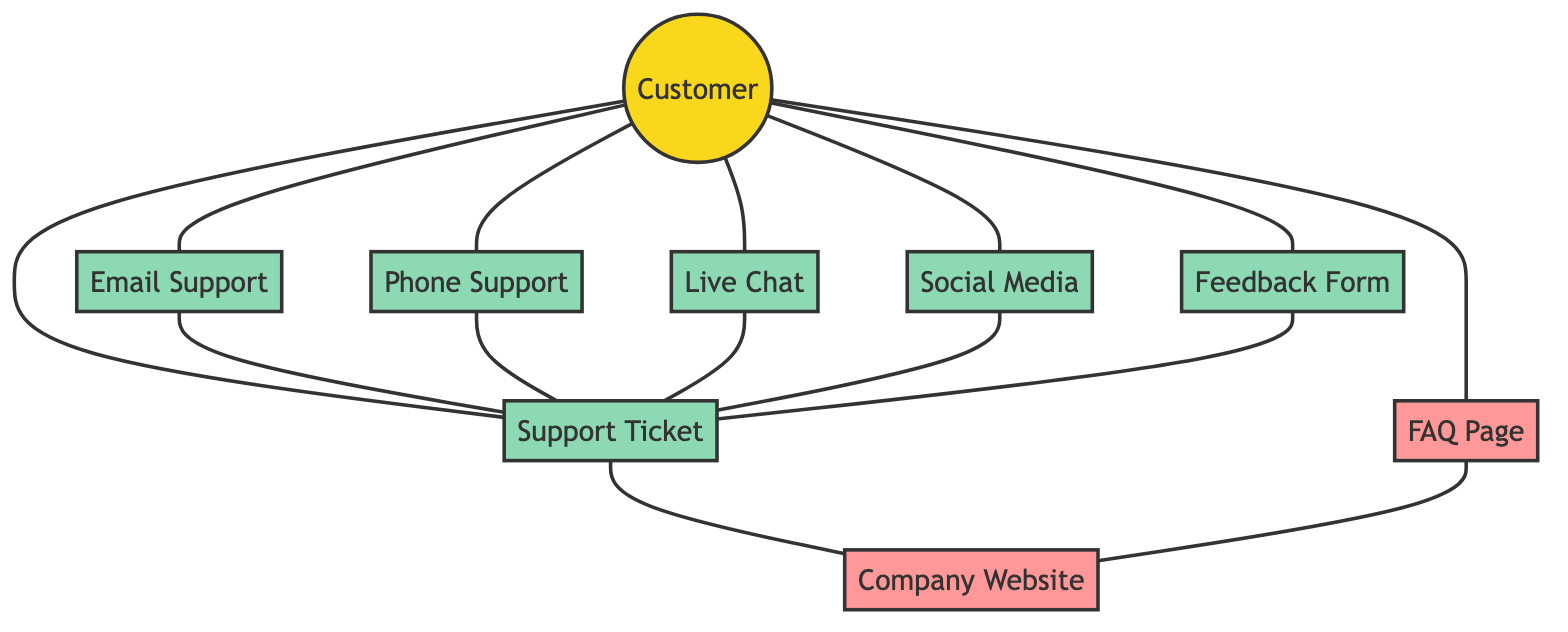What is the total number of nodes in the diagram? The nodes in the diagram are: Customer, Email Support, Phone Support, Live Chat, Social Media, Feedback Form, Support Ticket, FAQ Page, and Company Website. Counting these gives a total of 9 nodes.
Answer: 9 Which support methods connect directly to the customer? The support methods that connect directly to the customer, as seen in the edges connected to the Customer node, are Email Support, Phone Support, Live Chat, Social Media, Feedback Form, and Support Ticket. There are 6 in total.
Answer: 6 What is the relationship between Support Ticket and Company Website? The edge in the diagram shows a direct connection between Support Ticket and Company Website. This indicates that the Support Ticket is associated with, or potentially leads to, the Company Website.
Answer: Direct connection How many support channels lead to the Support Ticket? The support channels that lead to the Support Ticket, based on the edges present in the diagram, are Email Support, Phone Support, Live Chat, Social Media, and Feedback Form, making a total of 5 channels leading to it.
Answer: 5 Which node serves as a common point of interaction between the Customer and the Company Website? The Support Ticket node acts as a common interaction point since it connects both the Customer and the Company Website. This implies that interactions initiated by the customer can lead to support tickets which then relate to the Company Website.
Answer: Support Ticket Which node is an alternative path to reach the Company Website besides the Support Ticket? The FAQ Page serves as another route to reach the Company Website, as it connects directly to the Company Website, allowing customers to access it through another channel.
Answer: FAQ Page What indicates that all support methods are utilized by the customer? The Customer node is connected to all support method nodes (Email Support, Phone Support, Live Chat, Social Media, Feedback Form, and Support Ticket), indicating that the customer has access to these support methods.
Answer: Direct connections Is there a scenario in which a customer would utilize the Company Website without using the Support Ticket? Yes, the customer can directly access the FAQ Page, which then connects to the Company Website, indicating an alternative way to reach the website without going through a Support Ticket.
Answer: Yes How many edges are there leading from the Customer node? The edges leading from the Customer node are: Email Support, Phone Support, Live Chat, Social Media, Feedback Form, Support Ticket, and FAQ Page. In total, there are 7 edges starting from the Customer node.
Answer: 7 